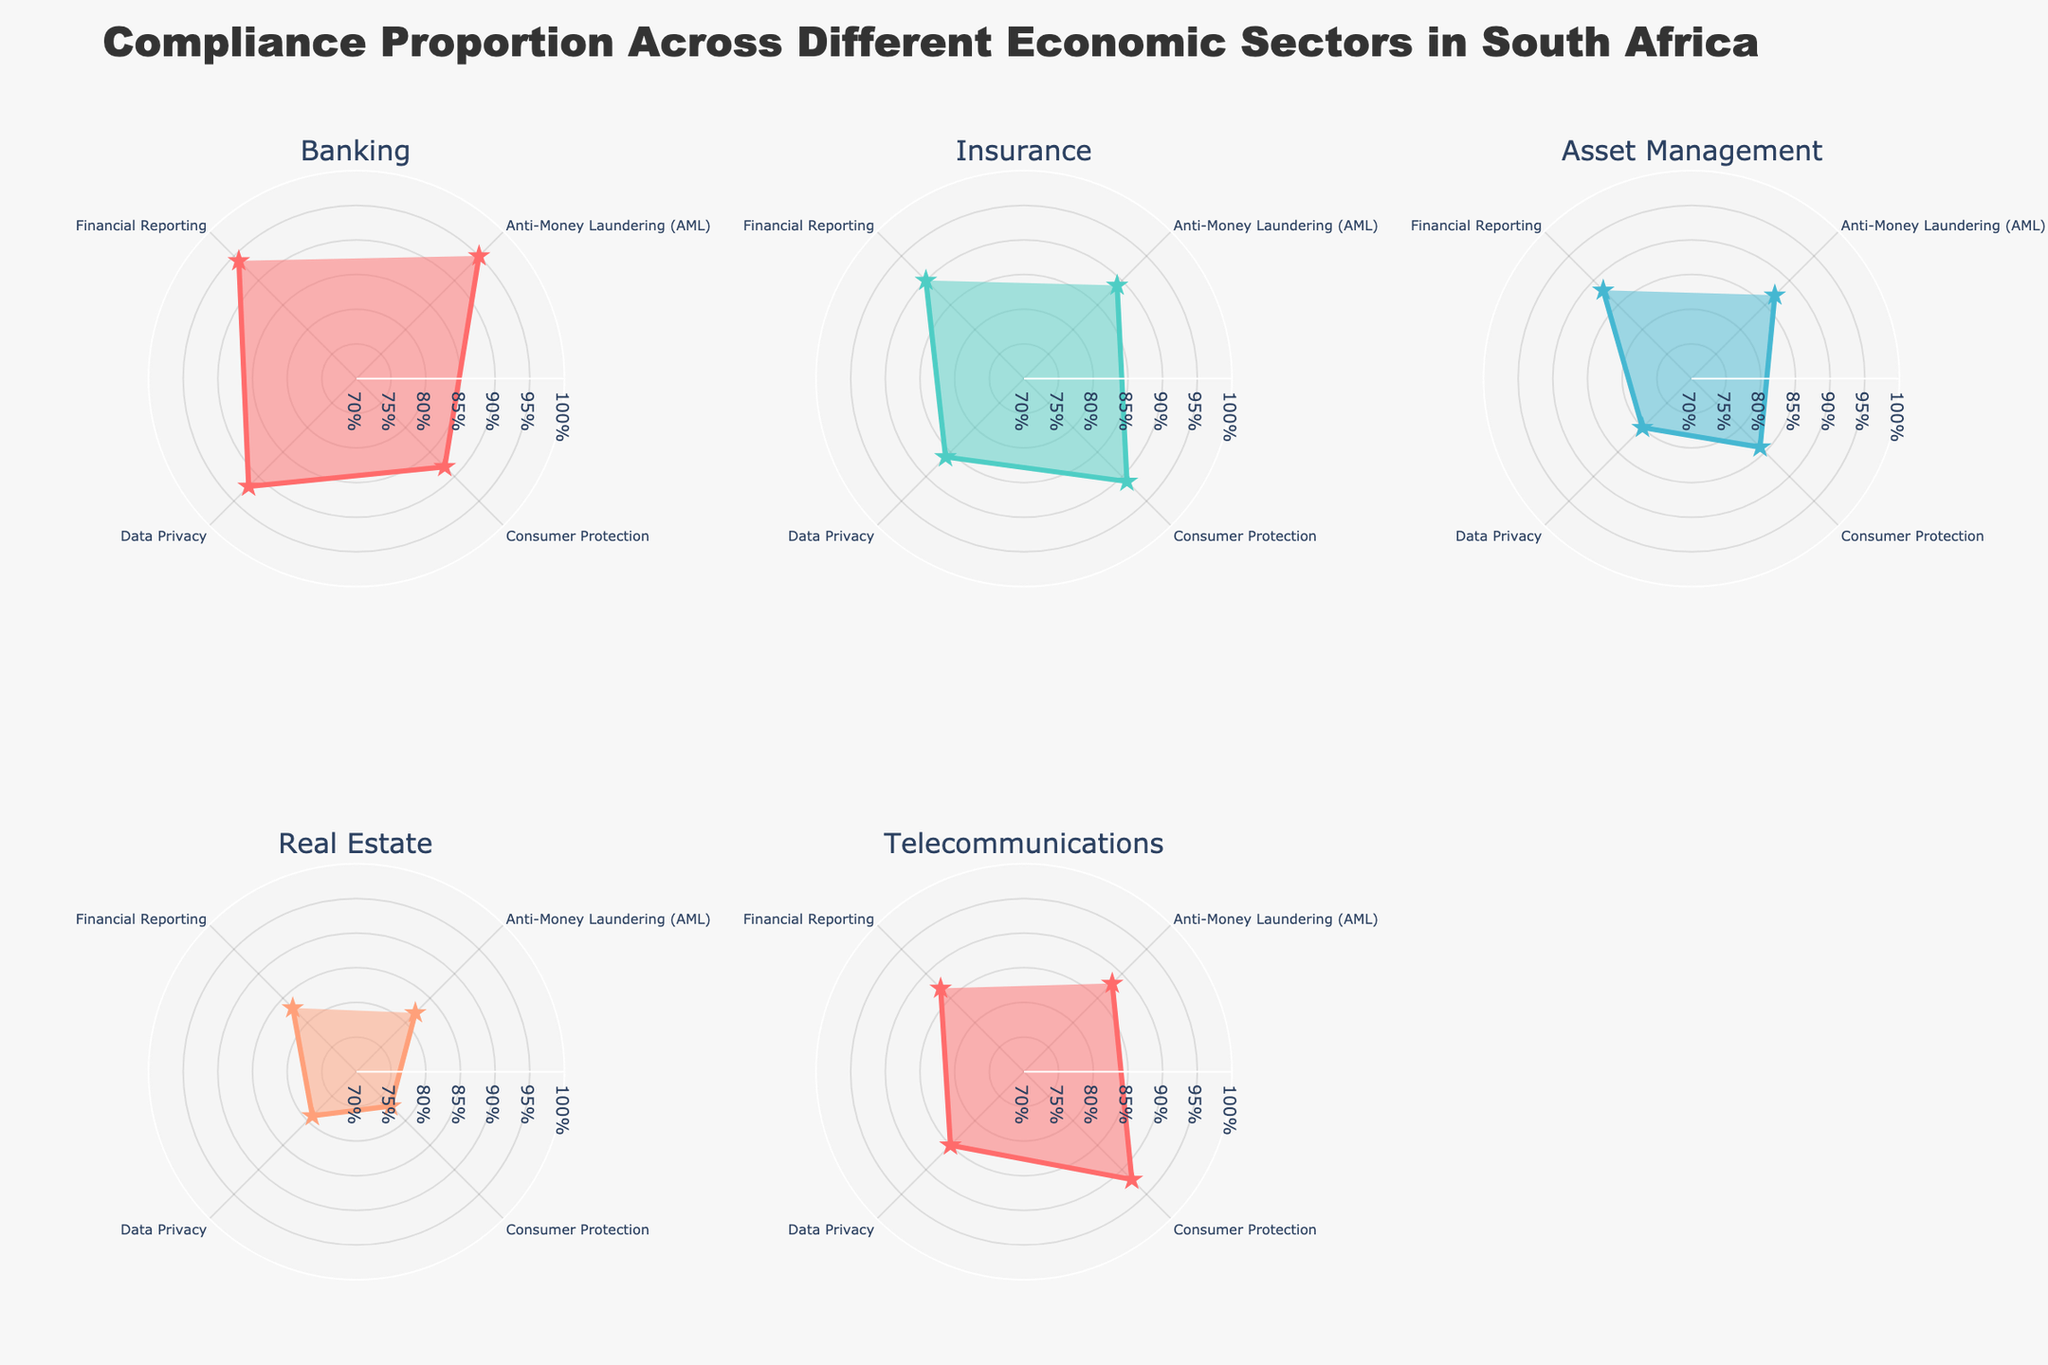How many different economic sectors are represented in the figure? There are six subplot titles, each representing a different economic sector. By counting the titles, we can see that there are six sectors in total: Banking, Insurance, Asset Management, Real Estate, and Telecommunications.
Answer: 6 Which economic sector has the highest compliance proportion for Anti-Money Laundering (AML)? The Banking sector shows the highest compliance proportion for AML, represented by the length of the blue line in the polar chart for Banking, which is longer and closer to the outer edge compared to other sectors.
Answer: Banking Compare the compliance proportions for Data Privacy between Banking and Insurance. Which sector shows higher compliance? Comparing the sections for Data Privacy in both the Banking and Insurance polar charts, the Banking sector has a higher level (closer to the outer edge of the chart) than Insurance. The proportion for Banking is 0.92, while for Insurance it is 0.86.
Answer: Banking What range is used for the radial axis on all polar charts? The radial axis visible on all the polar charts ranges from 0.7 to 1, indicated by the grid lines and axis labels in the subplot.
Answer: 0.7 to 1 Which economic sector has the lowest compliance proportion for Consumer Protection, and what is the value? The Real Estate sector shows the lowest compliance proportion for Consumer Protection. This is indicated by the shortest line in the polar chart for the Real Estate sector, with a compliance proportion value of 0.77.
Answer: Real Estate, 0.77 What is the average compliance proportion for Financial Reporting across all economic sectors? To find the average compliance proportion for Financial Reporting, sum up the proportions from each sector and divide by the number of sectors: (0.94 + 0.90 + 0.88 + 0.83 + 0.87) / 5. The sum is 4.42, so the average is 4.42 / 5 = 0.884.
Answer: 0.884 Which regulation type shows the most uniform compliance proportion across different economic sectors? Observing each polar chart, Anti-Money Laundering (AML) compliance proportions seem to be the most uniform, all ranging between 0.82 and 0.95 with less variation compared to compliance proportions for other regulation types.
Answer: Anti-Money Laundering (AML) In which economic sector is the compliance proportion for Data Privacy closest to the radial axis midpoint of 0.85? The Real Estate sector's Data Privacy compliance proportion is closest to the radial axis midpoint of 0.85, marked at 0.79 which is near the midpoint when compared to other sectors' proportions for the same regulation type.
Answer: Real Estate Considering the plot layout, which economic sector does not have neighboring subplots in all directions (i.e., is at an edge or corner)? The Real Estate sector is positioned in the bottom-left corner, meaning it doesn't have neighboring subplots in all directions and is at an edge/corner of the plot layout.
Answer: Real Estate 